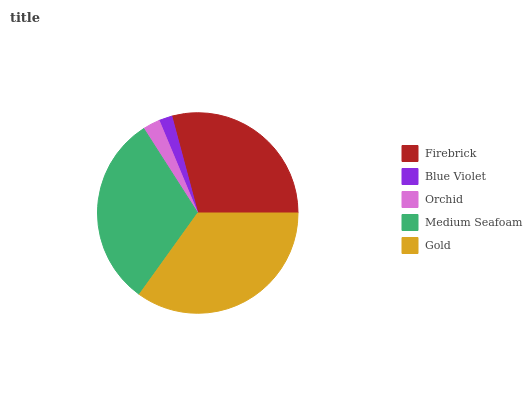Is Blue Violet the minimum?
Answer yes or no. Yes. Is Gold the maximum?
Answer yes or no. Yes. Is Orchid the minimum?
Answer yes or no. No. Is Orchid the maximum?
Answer yes or no. No. Is Orchid greater than Blue Violet?
Answer yes or no. Yes. Is Blue Violet less than Orchid?
Answer yes or no. Yes. Is Blue Violet greater than Orchid?
Answer yes or no. No. Is Orchid less than Blue Violet?
Answer yes or no. No. Is Firebrick the high median?
Answer yes or no. Yes. Is Firebrick the low median?
Answer yes or no. Yes. Is Blue Violet the high median?
Answer yes or no. No. Is Gold the low median?
Answer yes or no. No. 